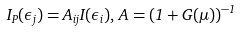<formula> <loc_0><loc_0><loc_500><loc_500>I _ { P } ( \epsilon _ { j } ) = { A } _ { i j } I ( \epsilon _ { i } ) , \, { A } = ( { 1 } + { G } ( \mu ) ) ^ { - 1 }</formula> 